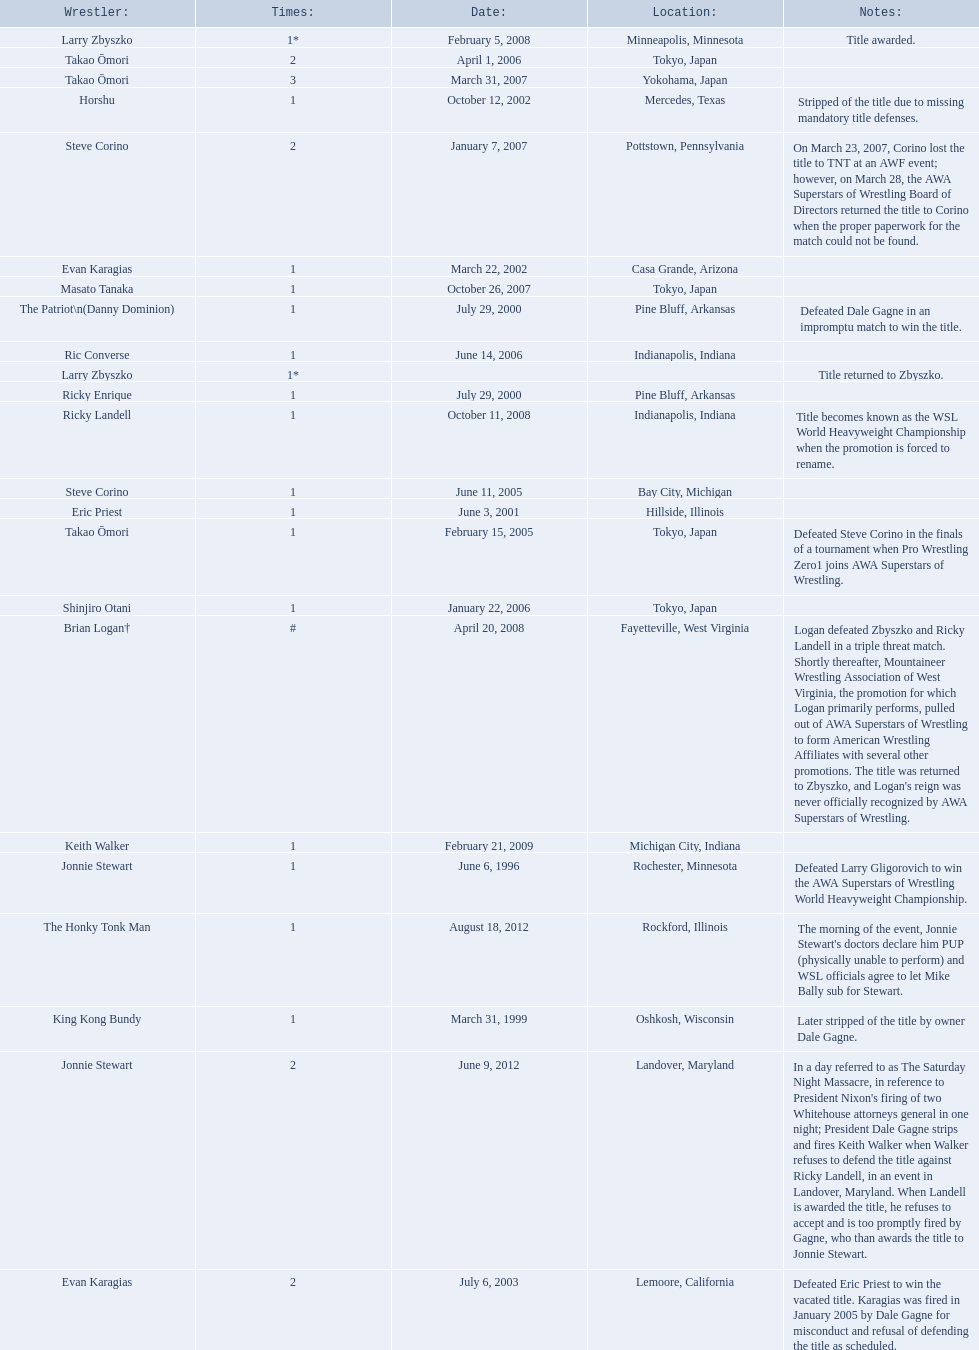Who are the wrestlers? Jonnie Stewart, Rochester, Minnesota, King Kong Bundy, Oshkosh, Wisconsin, The Patriot\n(Danny Dominion), Pine Bluff, Arkansas, Ricky Enrique, Pine Bluff, Arkansas, Eric Priest, Hillside, Illinois, Evan Karagias, Casa Grande, Arizona, Horshu, Mercedes, Texas, Evan Karagias, Lemoore, California, Takao Ōmori, Tokyo, Japan, Steve Corino, Bay City, Michigan, Shinjiro Otani, Tokyo, Japan, Takao Ōmori, Tokyo, Japan, Ric Converse, Indianapolis, Indiana, Steve Corino, Pottstown, Pennsylvania, Takao Ōmori, Yokohama, Japan, Masato Tanaka, Tokyo, Japan, Larry Zbyszko, Minneapolis, Minnesota, Brian Logan†, Fayetteville, West Virginia, Larry Zbyszko, , Ricky Landell, Indianapolis, Indiana, Keith Walker, Michigan City, Indiana, Jonnie Stewart, Landover, Maryland, The Honky Tonk Man, Rockford, Illinois. Who was from texas? Horshu, Mercedes, Texas. Who is he? Horshu. 